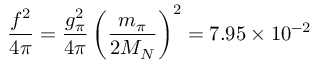Convert formula to latex. <formula><loc_0><loc_0><loc_500><loc_500>\frac { f ^ { 2 } } { 4 \pi } = \frac { g _ { \pi } ^ { 2 } } { 4 \pi } \left ( \frac { m _ { \pi } } { 2 M _ { N } } \right ) ^ { 2 } = 7 . 9 5 \times 1 0 ^ { - 2 }</formula> 